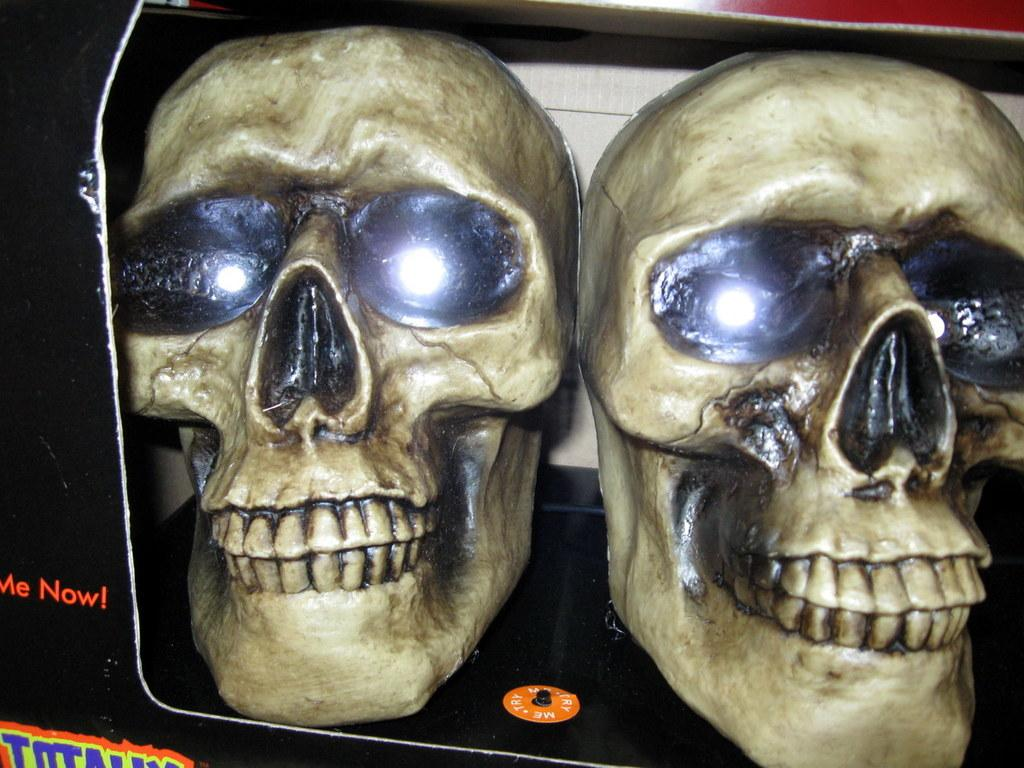What objects are present in the image? There are two skulls in the image. Where are the skulls located? The skulls are in a box. What feature do the skulls have? The skulls have lights on their eyes. Is there any text in the image? Yes, there is writing on the left side of the image. What type of fowl can be seen in the image? There is no fowl present in the image; it features two skulls in a box with lights on their eyes and writing on the left side. Is there a rifle visible in the image? No, there is no rifle present in the image. 